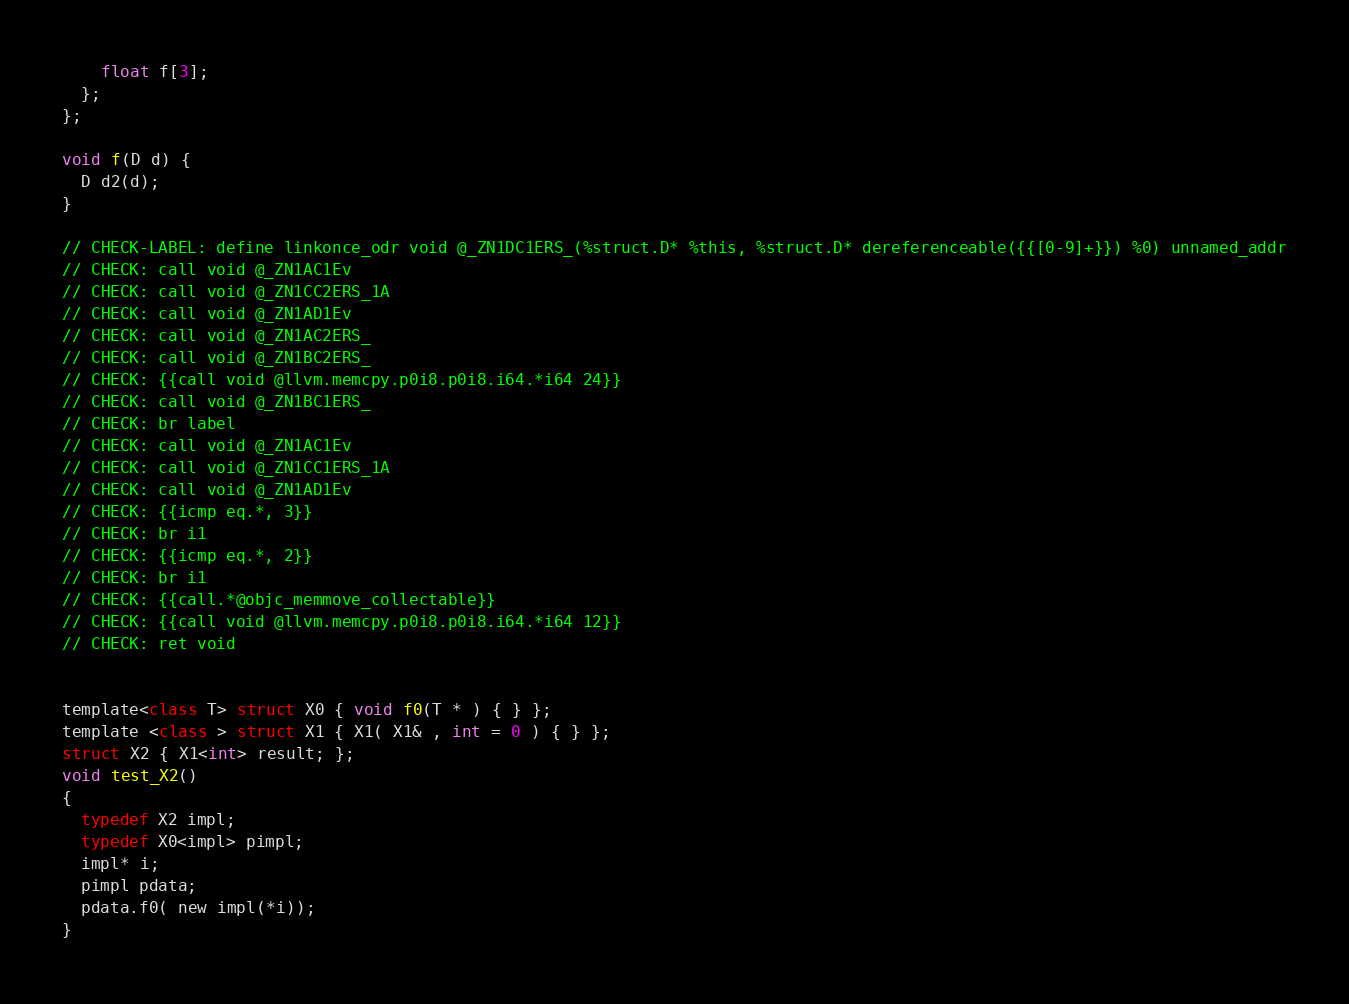<code> <loc_0><loc_0><loc_500><loc_500><_ObjectiveC_>    float f[3];
  };
};

void f(D d) {
  D d2(d);
}

// CHECK-LABEL: define linkonce_odr void @_ZN1DC1ERS_(%struct.D* %this, %struct.D* dereferenceable({{[0-9]+}}) %0) unnamed_addr
// CHECK: call void @_ZN1AC1Ev
// CHECK: call void @_ZN1CC2ERS_1A
// CHECK: call void @_ZN1AD1Ev
// CHECK: call void @_ZN1AC2ERS_
// CHECK: call void @_ZN1BC2ERS_
// CHECK: {{call void @llvm.memcpy.p0i8.p0i8.i64.*i64 24}}
// CHECK: call void @_ZN1BC1ERS_
// CHECK: br label
// CHECK: call void @_ZN1AC1Ev
// CHECK: call void @_ZN1CC1ERS_1A
// CHECK: call void @_ZN1AD1Ev
// CHECK: {{icmp eq.*, 3}}
// CHECK: br i1
// CHECK: {{icmp eq.*, 2}}
// CHECK: br i1
// CHECK: {{call.*@objc_memmove_collectable}}
// CHECK: {{call void @llvm.memcpy.p0i8.p0i8.i64.*i64 12}}
// CHECK: ret void


template<class T> struct X0 { void f0(T * ) { } };
template <class > struct X1 { X1( X1& , int = 0 ) { } };
struct X2 { X1<int> result; };
void test_X2()
{
  typedef X2 impl;
  typedef X0<impl> pimpl;
  impl* i;
  pimpl pdata;
  pdata.f0( new impl(*i));
}
</code> 